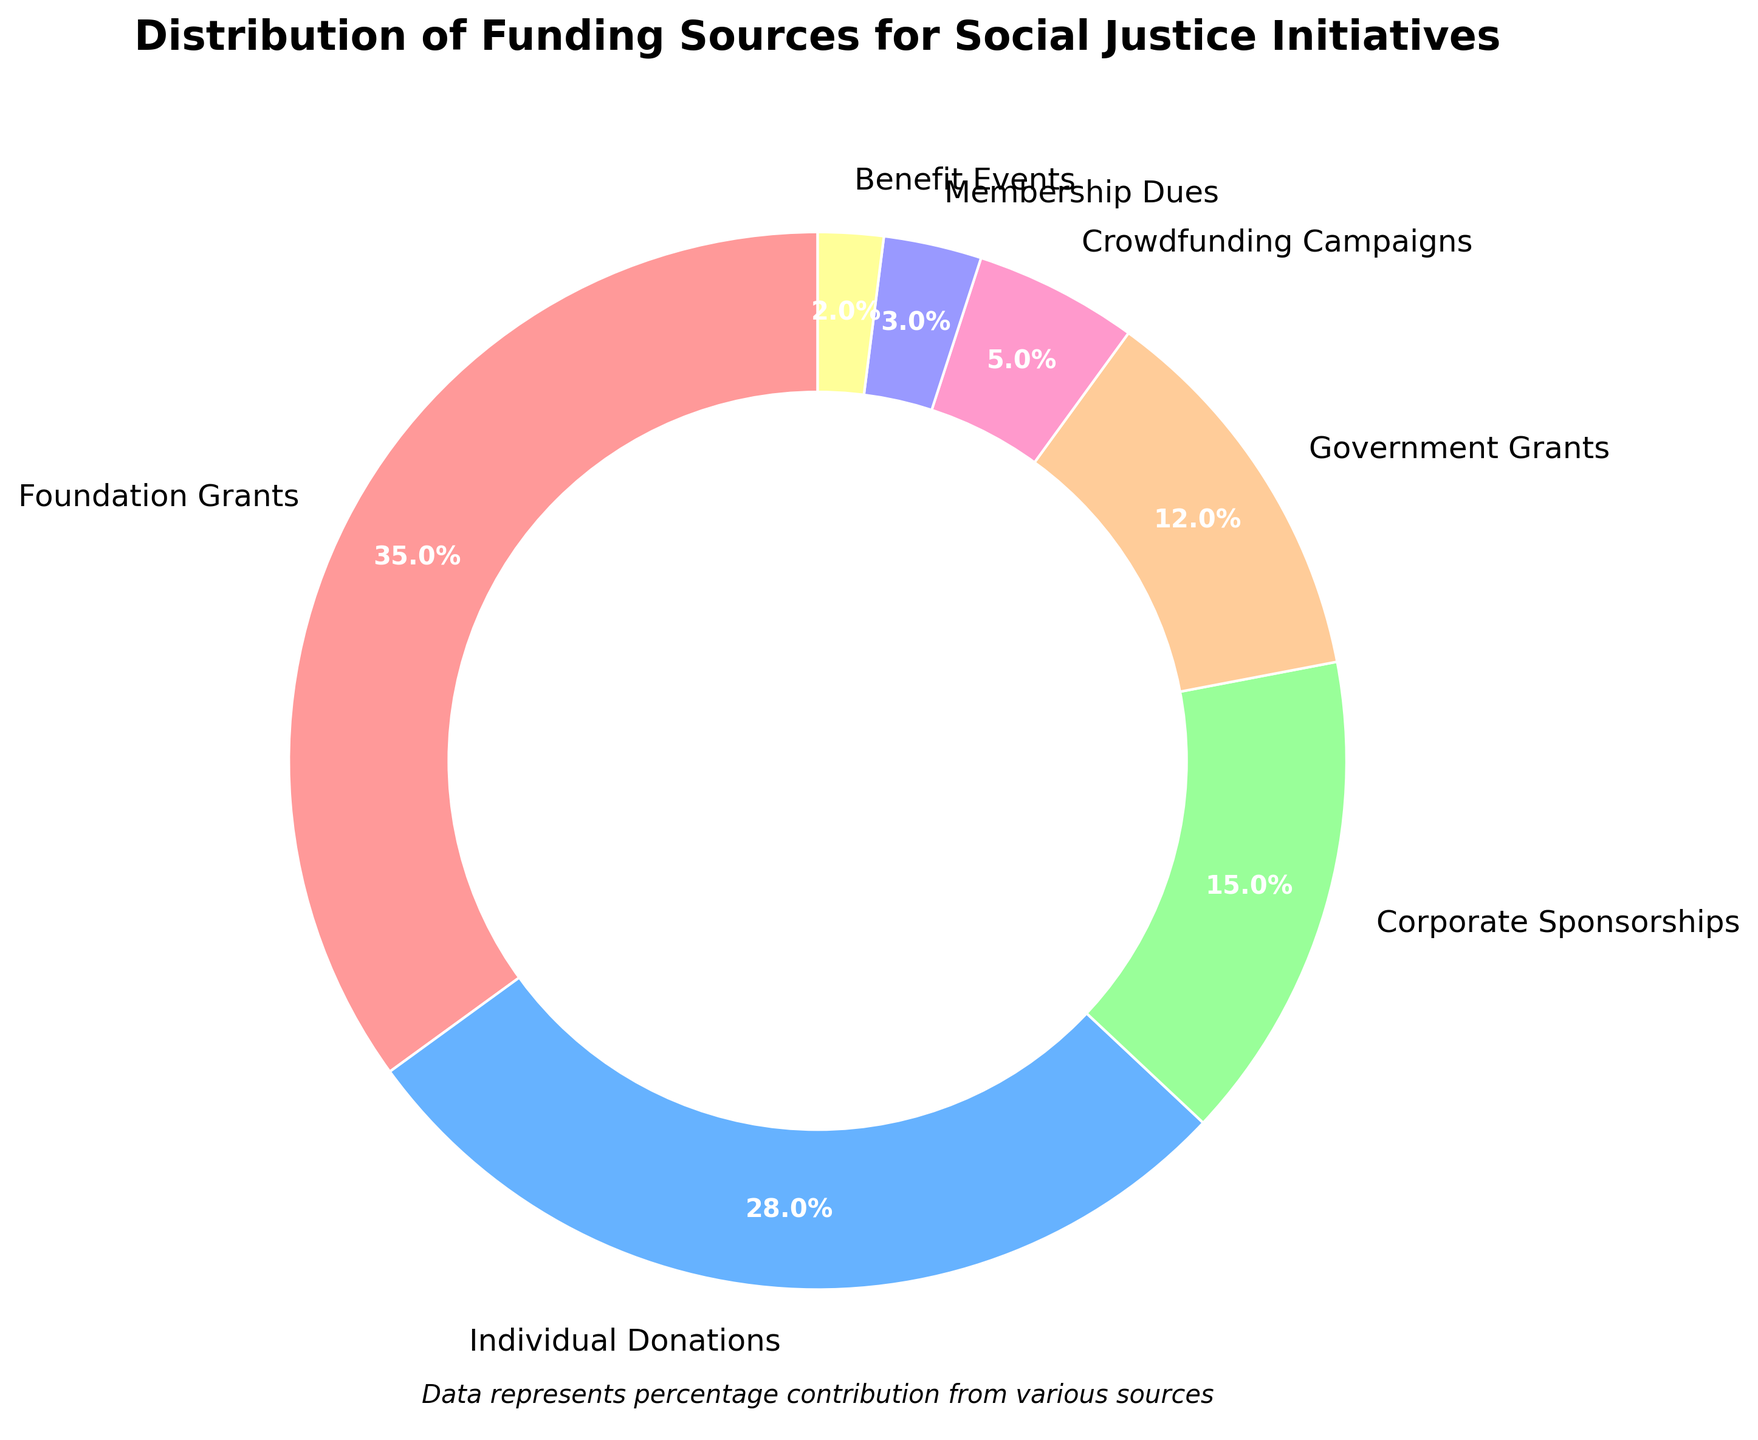What is the largest source of funding in the pie chart? The largest portion of the pie chart is labeled "Foundation Grants," which makes up 35% of the total funding.
Answer: Foundation Grants Which funding source is smaller, Government Grants or Corporate Sponsorships? Government Grants make up 12% of the funding, whereas Corporate Sponsorships contribute 15%. Hence, Government Grants are smaller.
Answer: Government Grants What percentage of funding comes from both Crowdfunding Campaigns and Membership Dues combined? Crowdfunding Campaigns contribute 5% and Membership Dues contribute 3%. Adding these together gives 5% + 3% = 8%.
Answer: 8% Which funding sources together make up more than 50% of the funding? Foundation Grants make up 35%, and Individual Donations make up 28%. Adding these together gives 35% + 28% = 63%, which is more than 50%.
Answer: Foundation Grants and Individual Donations How much more does Foundation Grants contribute compared to Individual Donations? Foundation Grants contribute 35%, and Individual Donations contribute 28%. The difference between them is 35% - 28% = 7%.
Answer: 7% What is the total percentage of funding contributed by Corporate Sponsorships, Crowdfunding Campaigns, and Benefit Events? Corporate Sponsorships contribute 15%, Crowdfunding Campaigns 5%, and Benefit Events 2%. Adding these together gives 15% + 5% + 2% = 22%.
Answer: 22% How does the contribution from Individual Donations compare to the total of Government Grants and Membership Dues? Individual Donations contribute 28%, while Government Grants and Membership Dues together contribute 12% + 3% = 15%. Thus, Individual Donations are larger.
Answer: Individual Donations Which color segment represents the smallest funding source? The smallest funding source is Benefit Events, making up 2% of the total. This segment is colored in yellow.
Answer: Yellow What's the percentage difference between the largest and smallest funding sources? The largest funding source is Foundation Grants at 35%, and the smallest is Benefit Events at 2%. The difference is 35% - 2% = 33%.
Answer: 33% 